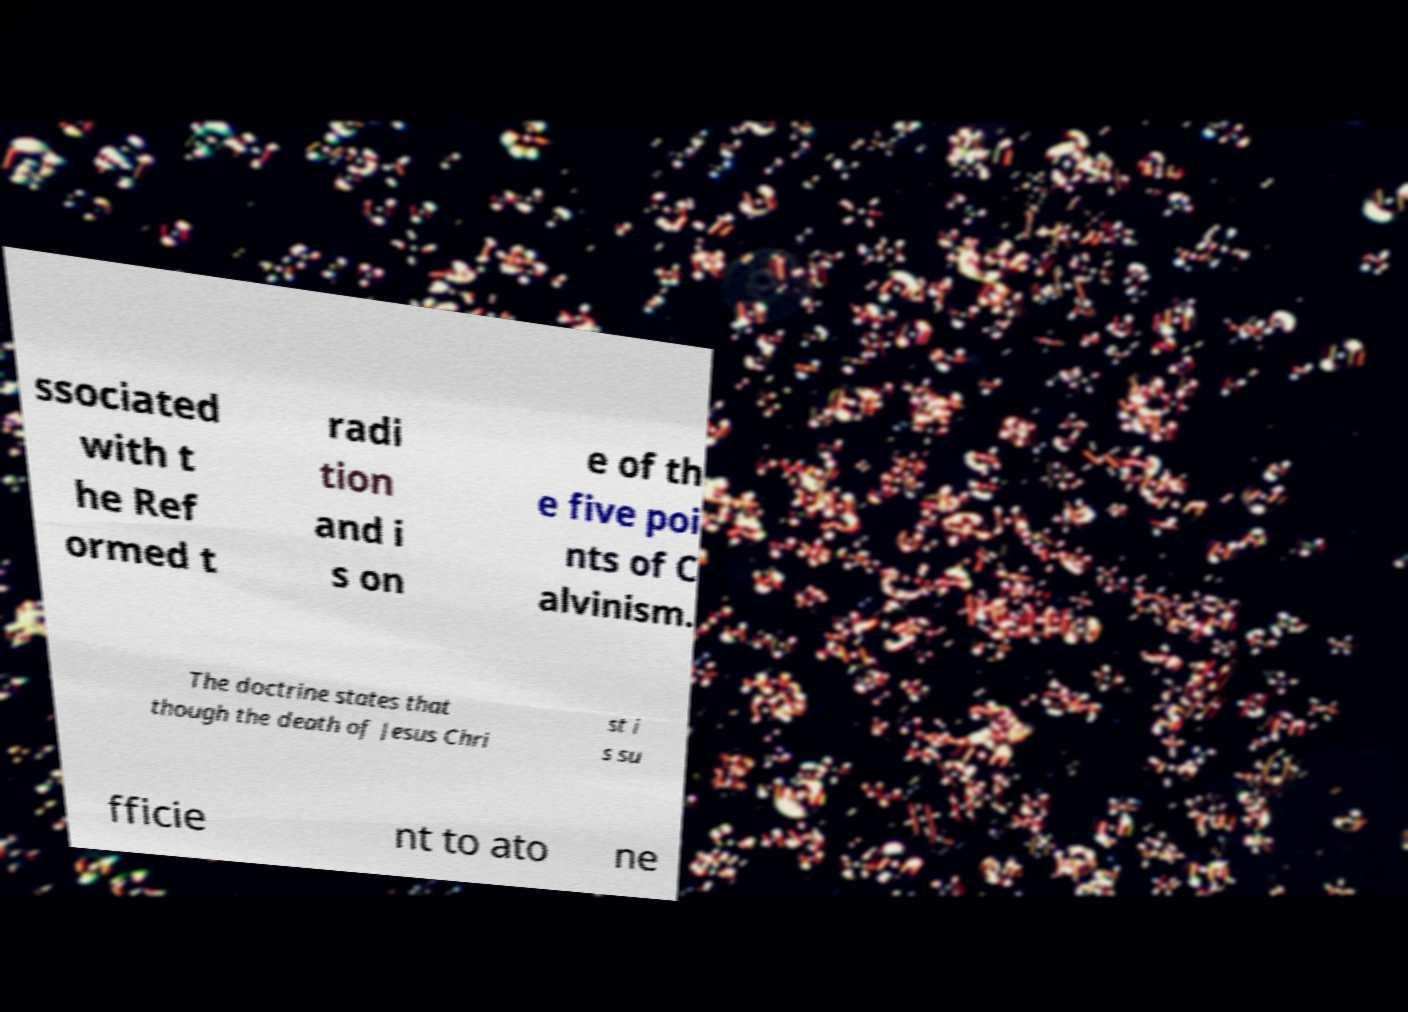Can you accurately transcribe the text from the provided image for me? ssociated with t he Ref ormed t radi tion and i s on e of th e five poi nts of C alvinism. The doctrine states that though the death of Jesus Chri st i s su fficie nt to ato ne 